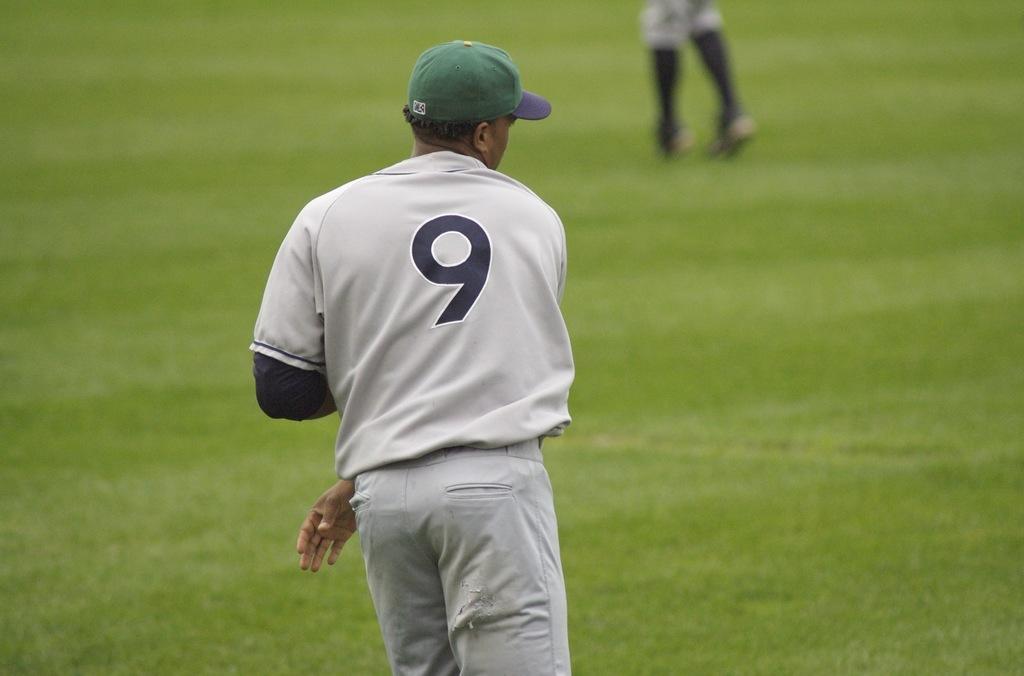Could you give a brief overview of what you see in this image? In the center of the image a man is standing and wearing a hat. In the background of the image grass is present. At the top of the image as person legs are there. 